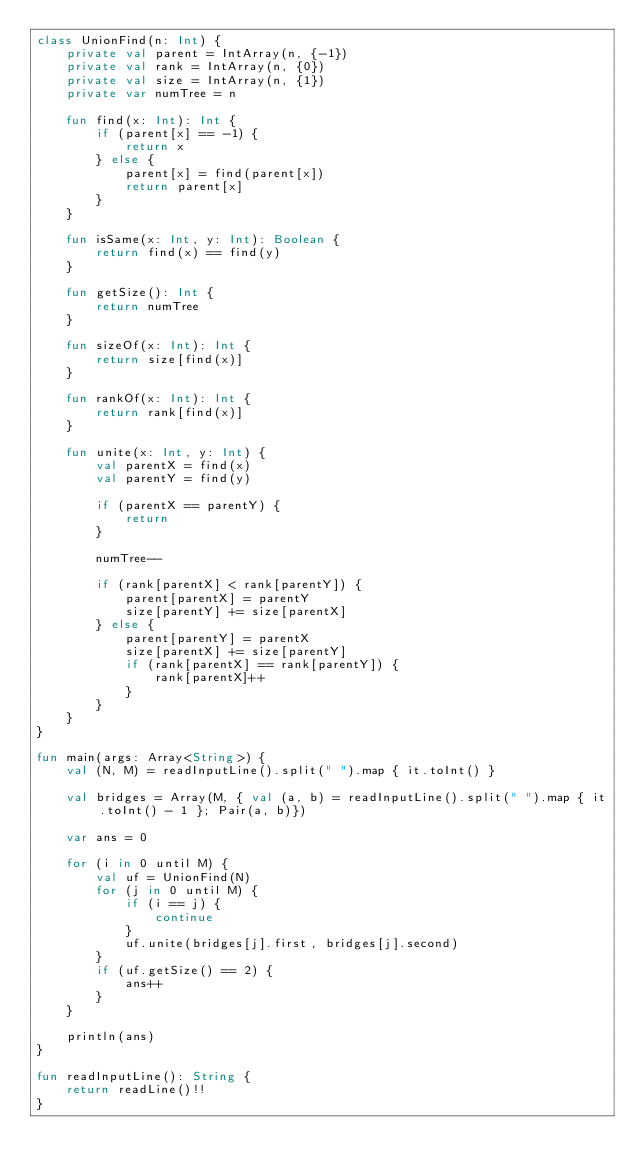Convert code to text. <code><loc_0><loc_0><loc_500><loc_500><_Kotlin_>class UnionFind(n: Int) {
    private val parent = IntArray(n, {-1})
    private val rank = IntArray(n, {0})
    private val size = IntArray(n, {1})
    private var numTree = n
    
    fun find(x: Int): Int {
        if (parent[x] == -1) {
            return x
        } else {
            parent[x] = find(parent[x])
            return parent[x]
        }
    }
    
    fun isSame(x: Int, y: Int): Boolean {
        return find(x) == find(y)
    }
    
    fun getSize(): Int {
        return numTree
    }
    
    fun sizeOf(x: Int): Int {
        return size[find(x)]
    }
    
    fun rankOf(x: Int): Int {
        return rank[find(x)]
    }
    
    fun unite(x: Int, y: Int) {
        val parentX = find(x)
        val parentY = find(y)
        
        if (parentX == parentY) {
            return
        }
        
        numTree--
        
        if (rank[parentX] < rank[parentY]) {
            parent[parentX] = parentY
            size[parentY] += size[parentX]
        } else {
            parent[parentY] = parentX
            size[parentX] += size[parentY]
            if (rank[parentX] == rank[parentY]) {
                rank[parentX]++
            }
        }
    }
}

fun main(args: Array<String>) {
    val (N, M) = readInputLine().split(" ").map { it.toInt() }
    
    val bridges = Array(M, { val (a, b) = readInputLine().split(" ").map { it.toInt() - 1 }; Pair(a, b)})
    
    var ans = 0
    
    for (i in 0 until M) {
        val uf = UnionFind(N)
        for (j in 0 until M) {
            if (i == j) {
                continue
            }
            uf.unite(bridges[j].first, bridges[j].second)
        }
        if (uf.getSize() == 2) {
            ans++
        }
    }
    
    println(ans)
}

fun readInputLine(): String {
    return readLine()!!
}

</code> 